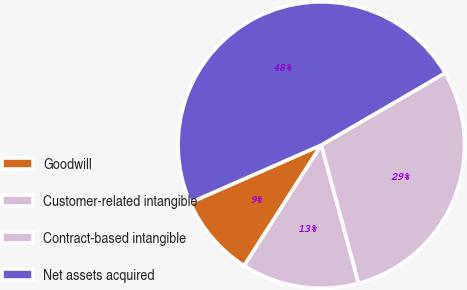Convert chart to OTSL. <chart><loc_0><loc_0><loc_500><loc_500><pie_chart><fcel>Goodwill<fcel>Customer-related intangible<fcel>Contract-based intangible<fcel>Net assets acquired<nl><fcel>9.36%<fcel>13.25%<fcel>29.19%<fcel>48.2%<nl></chart> 